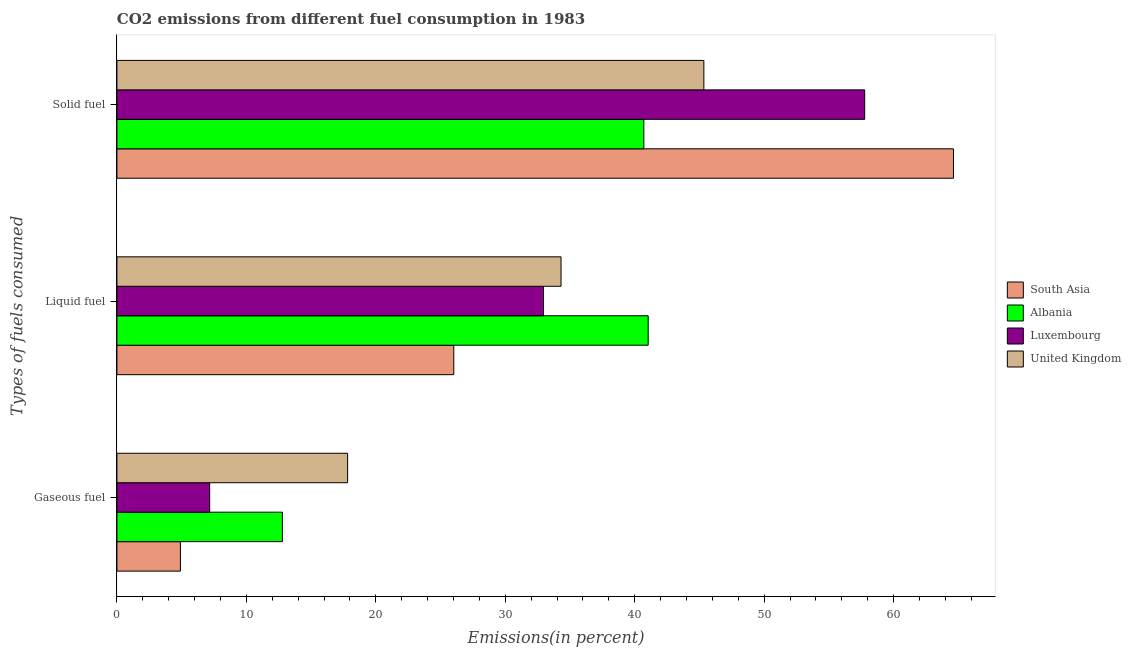How many different coloured bars are there?
Offer a very short reply. 4. Are the number of bars per tick equal to the number of legend labels?
Make the answer very short. Yes. Are the number of bars on each tick of the Y-axis equal?
Provide a succinct answer. Yes. How many bars are there on the 3rd tick from the top?
Ensure brevity in your answer.  4. What is the label of the 2nd group of bars from the top?
Your response must be concise. Liquid fuel. What is the percentage of liquid fuel emission in South Asia?
Your answer should be compact. 26.02. Across all countries, what is the maximum percentage of liquid fuel emission?
Keep it short and to the point. 41.04. Across all countries, what is the minimum percentage of gaseous fuel emission?
Your response must be concise. 4.9. In which country was the percentage of solid fuel emission maximum?
Offer a terse response. South Asia. In which country was the percentage of solid fuel emission minimum?
Provide a short and direct response. Albania. What is the total percentage of solid fuel emission in the graph?
Your answer should be compact. 208.42. What is the difference between the percentage of gaseous fuel emission in Luxembourg and that in Albania?
Offer a very short reply. -5.62. What is the difference between the percentage of solid fuel emission in Albania and the percentage of gaseous fuel emission in South Asia?
Your response must be concise. 35.8. What is the average percentage of liquid fuel emission per country?
Provide a succinct answer. 33.58. What is the difference between the percentage of gaseous fuel emission and percentage of solid fuel emission in Albania?
Your answer should be very brief. -27.92. In how many countries, is the percentage of gaseous fuel emission greater than 42 %?
Your response must be concise. 0. What is the ratio of the percentage of liquid fuel emission in United Kingdom to that in Luxembourg?
Your response must be concise. 1.04. Is the percentage of solid fuel emission in South Asia less than that in Albania?
Provide a short and direct response. No. What is the difference between the highest and the second highest percentage of gaseous fuel emission?
Offer a terse response. 5.04. What is the difference between the highest and the lowest percentage of solid fuel emission?
Give a very brief answer. 23.92. In how many countries, is the percentage of liquid fuel emission greater than the average percentage of liquid fuel emission taken over all countries?
Your response must be concise. 2. What does the 3rd bar from the top in Liquid fuel represents?
Your answer should be very brief. Albania. What does the 1st bar from the bottom in Liquid fuel represents?
Your answer should be very brief. South Asia. Is it the case that in every country, the sum of the percentage of gaseous fuel emission and percentage of liquid fuel emission is greater than the percentage of solid fuel emission?
Offer a very short reply. No. How many bars are there?
Ensure brevity in your answer.  12. How many countries are there in the graph?
Make the answer very short. 4. Does the graph contain grids?
Your answer should be very brief. No. How are the legend labels stacked?
Make the answer very short. Vertical. What is the title of the graph?
Give a very brief answer. CO2 emissions from different fuel consumption in 1983. What is the label or title of the X-axis?
Offer a terse response. Emissions(in percent). What is the label or title of the Y-axis?
Give a very brief answer. Types of fuels consumed. What is the Emissions(in percent) of South Asia in Gaseous fuel?
Your response must be concise. 4.9. What is the Emissions(in percent) of Albania in Gaseous fuel?
Your response must be concise. 12.78. What is the Emissions(in percent) of Luxembourg in Gaseous fuel?
Your answer should be very brief. 7.16. What is the Emissions(in percent) of United Kingdom in Gaseous fuel?
Your answer should be compact. 17.82. What is the Emissions(in percent) in South Asia in Liquid fuel?
Offer a very short reply. 26.02. What is the Emissions(in percent) in Albania in Liquid fuel?
Your answer should be very brief. 41.04. What is the Emissions(in percent) in Luxembourg in Liquid fuel?
Make the answer very short. 32.95. What is the Emissions(in percent) of United Kingdom in Liquid fuel?
Make the answer very short. 34.31. What is the Emissions(in percent) in South Asia in Solid fuel?
Your response must be concise. 64.62. What is the Emissions(in percent) in Albania in Solid fuel?
Provide a succinct answer. 40.7. What is the Emissions(in percent) of Luxembourg in Solid fuel?
Provide a succinct answer. 57.76. What is the Emissions(in percent) of United Kingdom in Solid fuel?
Provide a short and direct response. 45.34. Across all Types of fuels consumed, what is the maximum Emissions(in percent) in South Asia?
Your response must be concise. 64.62. Across all Types of fuels consumed, what is the maximum Emissions(in percent) in Albania?
Your response must be concise. 41.04. Across all Types of fuels consumed, what is the maximum Emissions(in percent) in Luxembourg?
Provide a short and direct response. 57.76. Across all Types of fuels consumed, what is the maximum Emissions(in percent) in United Kingdom?
Your answer should be compact. 45.34. Across all Types of fuels consumed, what is the minimum Emissions(in percent) in South Asia?
Offer a very short reply. 4.9. Across all Types of fuels consumed, what is the minimum Emissions(in percent) in Albania?
Provide a short and direct response. 12.78. Across all Types of fuels consumed, what is the minimum Emissions(in percent) of Luxembourg?
Provide a short and direct response. 7.16. Across all Types of fuels consumed, what is the minimum Emissions(in percent) of United Kingdom?
Provide a short and direct response. 17.82. What is the total Emissions(in percent) of South Asia in the graph?
Offer a terse response. 95.55. What is the total Emissions(in percent) in Albania in the graph?
Give a very brief answer. 94.52. What is the total Emissions(in percent) in Luxembourg in the graph?
Provide a succinct answer. 97.88. What is the total Emissions(in percent) in United Kingdom in the graph?
Offer a very short reply. 97.46. What is the difference between the Emissions(in percent) of South Asia in Gaseous fuel and that in Liquid fuel?
Offer a terse response. -21.12. What is the difference between the Emissions(in percent) in Albania in Gaseous fuel and that in Liquid fuel?
Make the answer very short. -28.26. What is the difference between the Emissions(in percent) in Luxembourg in Gaseous fuel and that in Liquid fuel?
Your response must be concise. -25.79. What is the difference between the Emissions(in percent) of United Kingdom in Gaseous fuel and that in Liquid fuel?
Ensure brevity in your answer.  -16.49. What is the difference between the Emissions(in percent) in South Asia in Gaseous fuel and that in Solid fuel?
Give a very brief answer. -59.72. What is the difference between the Emissions(in percent) in Albania in Gaseous fuel and that in Solid fuel?
Make the answer very short. -27.92. What is the difference between the Emissions(in percent) in Luxembourg in Gaseous fuel and that in Solid fuel?
Your answer should be compact. -50.6. What is the difference between the Emissions(in percent) in United Kingdom in Gaseous fuel and that in Solid fuel?
Your response must be concise. -27.52. What is the difference between the Emissions(in percent) in South Asia in Liquid fuel and that in Solid fuel?
Keep it short and to the point. -38.6. What is the difference between the Emissions(in percent) of Albania in Liquid fuel and that in Solid fuel?
Your response must be concise. 0.34. What is the difference between the Emissions(in percent) of Luxembourg in Liquid fuel and that in Solid fuel?
Keep it short and to the point. -24.81. What is the difference between the Emissions(in percent) of United Kingdom in Liquid fuel and that in Solid fuel?
Make the answer very short. -11.03. What is the difference between the Emissions(in percent) of South Asia in Gaseous fuel and the Emissions(in percent) of Albania in Liquid fuel?
Keep it short and to the point. -36.13. What is the difference between the Emissions(in percent) in South Asia in Gaseous fuel and the Emissions(in percent) in Luxembourg in Liquid fuel?
Keep it short and to the point. -28.05. What is the difference between the Emissions(in percent) in South Asia in Gaseous fuel and the Emissions(in percent) in United Kingdom in Liquid fuel?
Make the answer very short. -29.4. What is the difference between the Emissions(in percent) of Albania in Gaseous fuel and the Emissions(in percent) of Luxembourg in Liquid fuel?
Provide a short and direct response. -20.17. What is the difference between the Emissions(in percent) of Albania in Gaseous fuel and the Emissions(in percent) of United Kingdom in Liquid fuel?
Provide a short and direct response. -21.52. What is the difference between the Emissions(in percent) in Luxembourg in Gaseous fuel and the Emissions(in percent) in United Kingdom in Liquid fuel?
Offer a terse response. -27.14. What is the difference between the Emissions(in percent) in South Asia in Gaseous fuel and the Emissions(in percent) in Albania in Solid fuel?
Offer a very short reply. -35.8. What is the difference between the Emissions(in percent) in South Asia in Gaseous fuel and the Emissions(in percent) in Luxembourg in Solid fuel?
Offer a very short reply. -52.86. What is the difference between the Emissions(in percent) of South Asia in Gaseous fuel and the Emissions(in percent) of United Kingdom in Solid fuel?
Your answer should be compact. -40.43. What is the difference between the Emissions(in percent) of Albania in Gaseous fuel and the Emissions(in percent) of Luxembourg in Solid fuel?
Offer a terse response. -44.98. What is the difference between the Emissions(in percent) in Albania in Gaseous fuel and the Emissions(in percent) in United Kingdom in Solid fuel?
Your answer should be very brief. -32.56. What is the difference between the Emissions(in percent) of Luxembourg in Gaseous fuel and the Emissions(in percent) of United Kingdom in Solid fuel?
Your response must be concise. -38.17. What is the difference between the Emissions(in percent) in South Asia in Liquid fuel and the Emissions(in percent) in Albania in Solid fuel?
Make the answer very short. -14.68. What is the difference between the Emissions(in percent) of South Asia in Liquid fuel and the Emissions(in percent) of Luxembourg in Solid fuel?
Provide a succinct answer. -31.74. What is the difference between the Emissions(in percent) in South Asia in Liquid fuel and the Emissions(in percent) in United Kingdom in Solid fuel?
Your response must be concise. -19.32. What is the difference between the Emissions(in percent) of Albania in Liquid fuel and the Emissions(in percent) of Luxembourg in Solid fuel?
Your answer should be compact. -16.72. What is the difference between the Emissions(in percent) in Albania in Liquid fuel and the Emissions(in percent) in United Kingdom in Solid fuel?
Your answer should be very brief. -4.3. What is the difference between the Emissions(in percent) of Luxembourg in Liquid fuel and the Emissions(in percent) of United Kingdom in Solid fuel?
Offer a terse response. -12.39. What is the average Emissions(in percent) in South Asia per Types of fuels consumed?
Ensure brevity in your answer.  31.85. What is the average Emissions(in percent) of Albania per Types of fuels consumed?
Make the answer very short. 31.51. What is the average Emissions(in percent) of Luxembourg per Types of fuels consumed?
Your response must be concise. 32.63. What is the average Emissions(in percent) of United Kingdom per Types of fuels consumed?
Keep it short and to the point. 32.49. What is the difference between the Emissions(in percent) in South Asia and Emissions(in percent) in Albania in Gaseous fuel?
Provide a short and direct response. -7.88. What is the difference between the Emissions(in percent) in South Asia and Emissions(in percent) in Luxembourg in Gaseous fuel?
Your response must be concise. -2.26. What is the difference between the Emissions(in percent) in South Asia and Emissions(in percent) in United Kingdom in Gaseous fuel?
Your answer should be very brief. -12.92. What is the difference between the Emissions(in percent) in Albania and Emissions(in percent) in Luxembourg in Gaseous fuel?
Make the answer very short. 5.62. What is the difference between the Emissions(in percent) of Albania and Emissions(in percent) of United Kingdom in Gaseous fuel?
Ensure brevity in your answer.  -5.04. What is the difference between the Emissions(in percent) in Luxembourg and Emissions(in percent) in United Kingdom in Gaseous fuel?
Give a very brief answer. -10.65. What is the difference between the Emissions(in percent) in South Asia and Emissions(in percent) in Albania in Liquid fuel?
Your answer should be very brief. -15.02. What is the difference between the Emissions(in percent) in South Asia and Emissions(in percent) in Luxembourg in Liquid fuel?
Your answer should be compact. -6.93. What is the difference between the Emissions(in percent) in South Asia and Emissions(in percent) in United Kingdom in Liquid fuel?
Your response must be concise. -8.28. What is the difference between the Emissions(in percent) in Albania and Emissions(in percent) in Luxembourg in Liquid fuel?
Give a very brief answer. 8.09. What is the difference between the Emissions(in percent) in Albania and Emissions(in percent) in United Kingdom in Liquid fuel?
Make the answer very short. 6.73. What is the difference between the Emissions(in percent) of Luxembourg and Emissions(in percent) of United Kingdom in Liquid fuel?
Provide a succinct answer. -1.36. What is the difference between the Emissions(in percent) in South Asia and Emissions(in percent) in Albania in Solid fuel?
Offer a terse response. 23.92. What is the difference between the Emissions(in percent) of South Asia and Emissions(in percent) of Luxembourg in Solid fuel?
Give a very brief answer. 6.86. What is the difference between the Emissions(in percent) of South Asia and Emissions(in percent) of United Kingdom in Solid fuel?
Provide a succinct answer. 19.28. What is the difference between the Emissions(in percent) of Albania and Emissions(in percent) of Luxembourg in Solid fuel?
Ensure brevity in your answer.  -17.06. What is the difference between the Emissions(in percent) of Albania and Emissions(in percent) of United Kingdom in Solid fuel?
Provide a succinct answer. -4.64. What is the difference between the Emissions(in percent) of Luxembourg and Emissions(in percent) of United Kingdom in Solid fuel?
Your answer should be compact. 12.42. What is the ratio of the Emissions(in percent) of South Asia in Gaseous fuel to that in Liquid fuel?
Provide a succinct answer. 0.19. What is the ratio of the Emissions(in percent) in Albania in Gaseous fuel to that in Liquid fuel?
Your answer should be compact. 0.31. What is the ratio of the Emissions(in percent) in Luxembourg in Gaseous fuel to that in Liquid fuel?
Offer a terse response. 0.22. What is the ratio of the Emissions(in percent) of United Kingdom in Gaseous fuel to that in Liquid fuel?
Your answer should be compact. 0.52. What is the ratio of the Emissions(in percent) in South Asia in Gaseous fuel to that in Solid fuel?
Provide a succinct answer. 0.08. What is the ratio of the Emissions(in percent) of Albania in Gaseous fuel to that in Solid fuel?
Offer a terse response. 0.31. What is the ratio of the Emissions(in percent) of Luxembourg in Gaseous fuel to that in Solid fuel?
Give a very brief answer. 0.12. What is the ratio of the Emissions(in percent) in United Kingdom in Gaseous fuel to that in Solid fuel?
Provide a short and direct response. 0.39. What is the ratio of the Emissions(in percent) of South Asia in Liquid fuel to that in Solid fuel?
Offer a terse response. 0.4. What is the ratio of the Emissions(in percent) of Albania in Liquid fuel to that in Solid fuel?
Give a very brief answer. 1.01. What is the ratio of the Emissions(in percent) of Luxembourg in Liquid fuel to that in Solid fuel?
Provide a short and direct response. 0.57. What is the ratio of the Emissions(in percent) in United Kingdom in Liquid fuel to that in Solid fuel?
Your answer should be very brief. 0.76. What is the difference between the highest and the second highest Emissions(in percent) of South Asia?
Your answer should be compact. 38.6. What is the difference between the highest and the second highest Emissions(in percent) of Albania?
Make the answer very short. 0.34. What is the difference between the highest and the second highest Emissions(in percent) of Luxembourg?
Offer a terse response. 24.81. What is the difference between the highest and the second highest Emissions(in percent) of United Kingdom?
Offer a terse response. 11.03. What is the difference between the highest and the lowest Emissions(in percent) of South Asia?
Provide a succinct answer. 59.72. What is the difference between the highest and the lowest Emissions(in percent) in Albania?
Your answer should be very brief. 28.26. What is the difference between the highest and the lowest Emissions(in percent) of Luxembourg?
Ensure brevity in your answer.  50.6. What is the difference between the highest and the lowest Emissions(in percent) in United Kingdom?
Give a very brief answer. 27.52. 